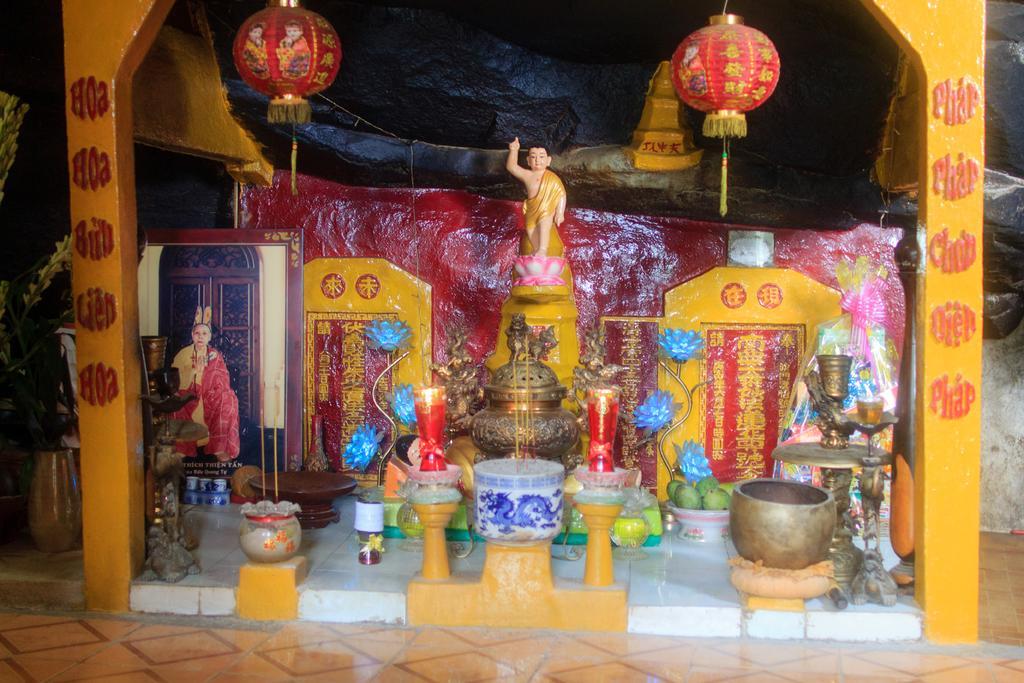Describe this image in one or two sentences. In this image I can see a mini sculpture, red and yellow colour wall, few glasses, few fruits in a white colour bowl, few red colour things and many more other stuffs. I can also see something is written on wall. 